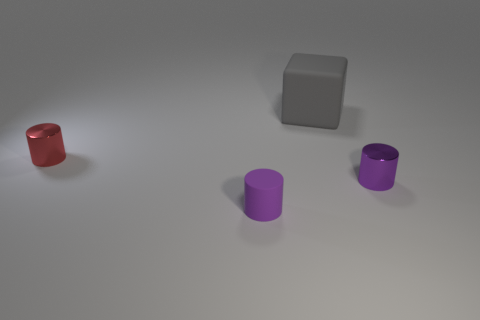Add 4 tiny purple metallic cubes. How many objects exist? 8 Subtract all blocks. How many objects are left? 3 Add 2 matte cubes. How many matte cubes exist? 3 Subtract 0 yellow cylinders. How many objects are left? 4 Subtract all big green rubber objects. Subtract all large gray matte blocks. How many objects are left? 3 Add 2 tiny matte things. How many tiny matte things are left? 3 